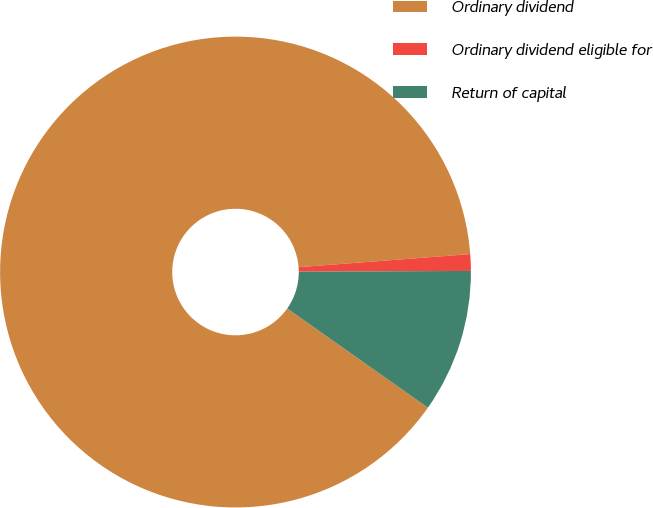Convert chart to OTSL. <chart><loc_0><loc_0><loc_500><loc_500><pie_chart><fcel>Ordinary dividend<fcel>Ordinary dividend eligible for<fcel>Return of capital<nl><fcel>89.02%<fcel>1.14%<fcel>9.85%<nl></chart> 